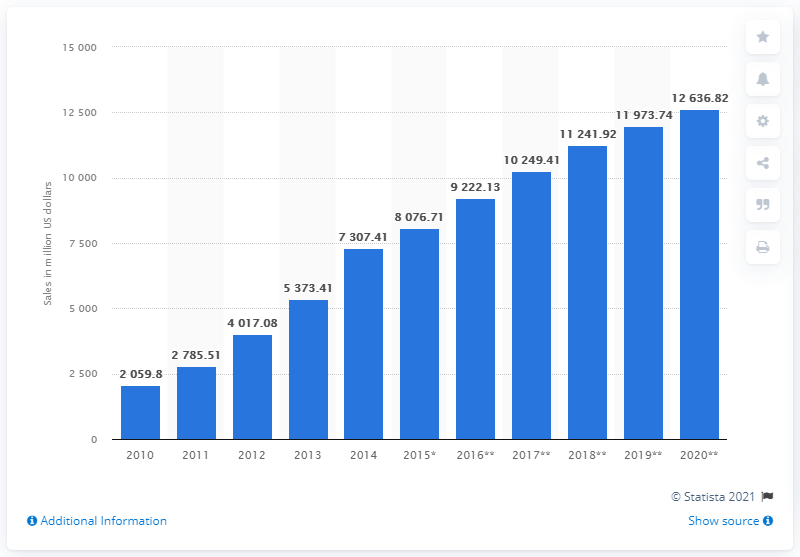Point out several critical features in this image. Aldi made approximately $205.98 billion in sales in 2010. The sales forecast for Aldi in the United Kingdom by 2020 is expected to be 12,636.82. 